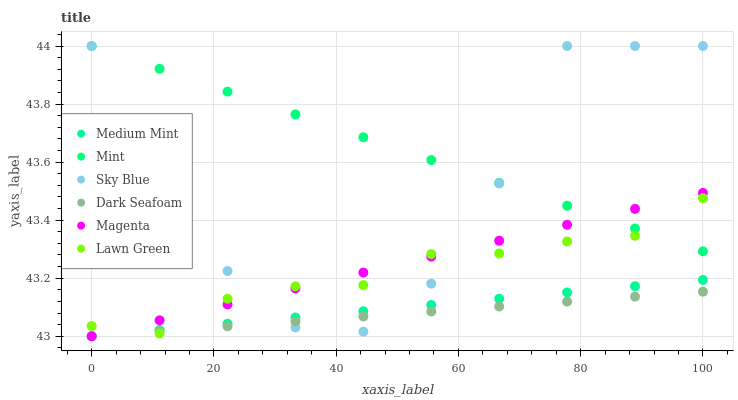Does Dark Seafoam have the minimum area under the curve?
Answer yes or no. Yes. Does Mint have the maximum area under the curve?
Answer yes or no. Yes. Does Lawn Green have the minimum area under the curve?
Answer yes or no. No. Does Lawn Green have the maximum area under the curve?
Answer yes or no. No. Is Magenta the smoothest?
Answer yes or no. Yes. Is Sky Blue the roughest?
Answer yes or no. Yes. Is Lawn Green the smoothest?
Answer yes or no. No. Is Lawn Green the roughest?
Answer yes or no. No. Does Medium Mint have the lowest value?
Answer yes or no. Yes. Does Lawn Green have the lowest value?
Answer yes or no. No. Does Mint have the highest value?
Answer yes or no. Yes. Does Lawn Green have the highest value?
Answer yes or no. No. Is Dark Seafoam less than Mint?
Answer yes or no. Yes. Is Mint greater than Dark Seafoam?
Answer yes or no. Yes. Does Mint intersect Sky Blue?
Answer yes or no. Yes. Is Mint less than Sky Blue?
Answer yes or no. No. Is Mint greater than Sky Blue?
Answer yes or no. No. Does Dark Seafoam intersect Mint?
Answer yes or no. No. 